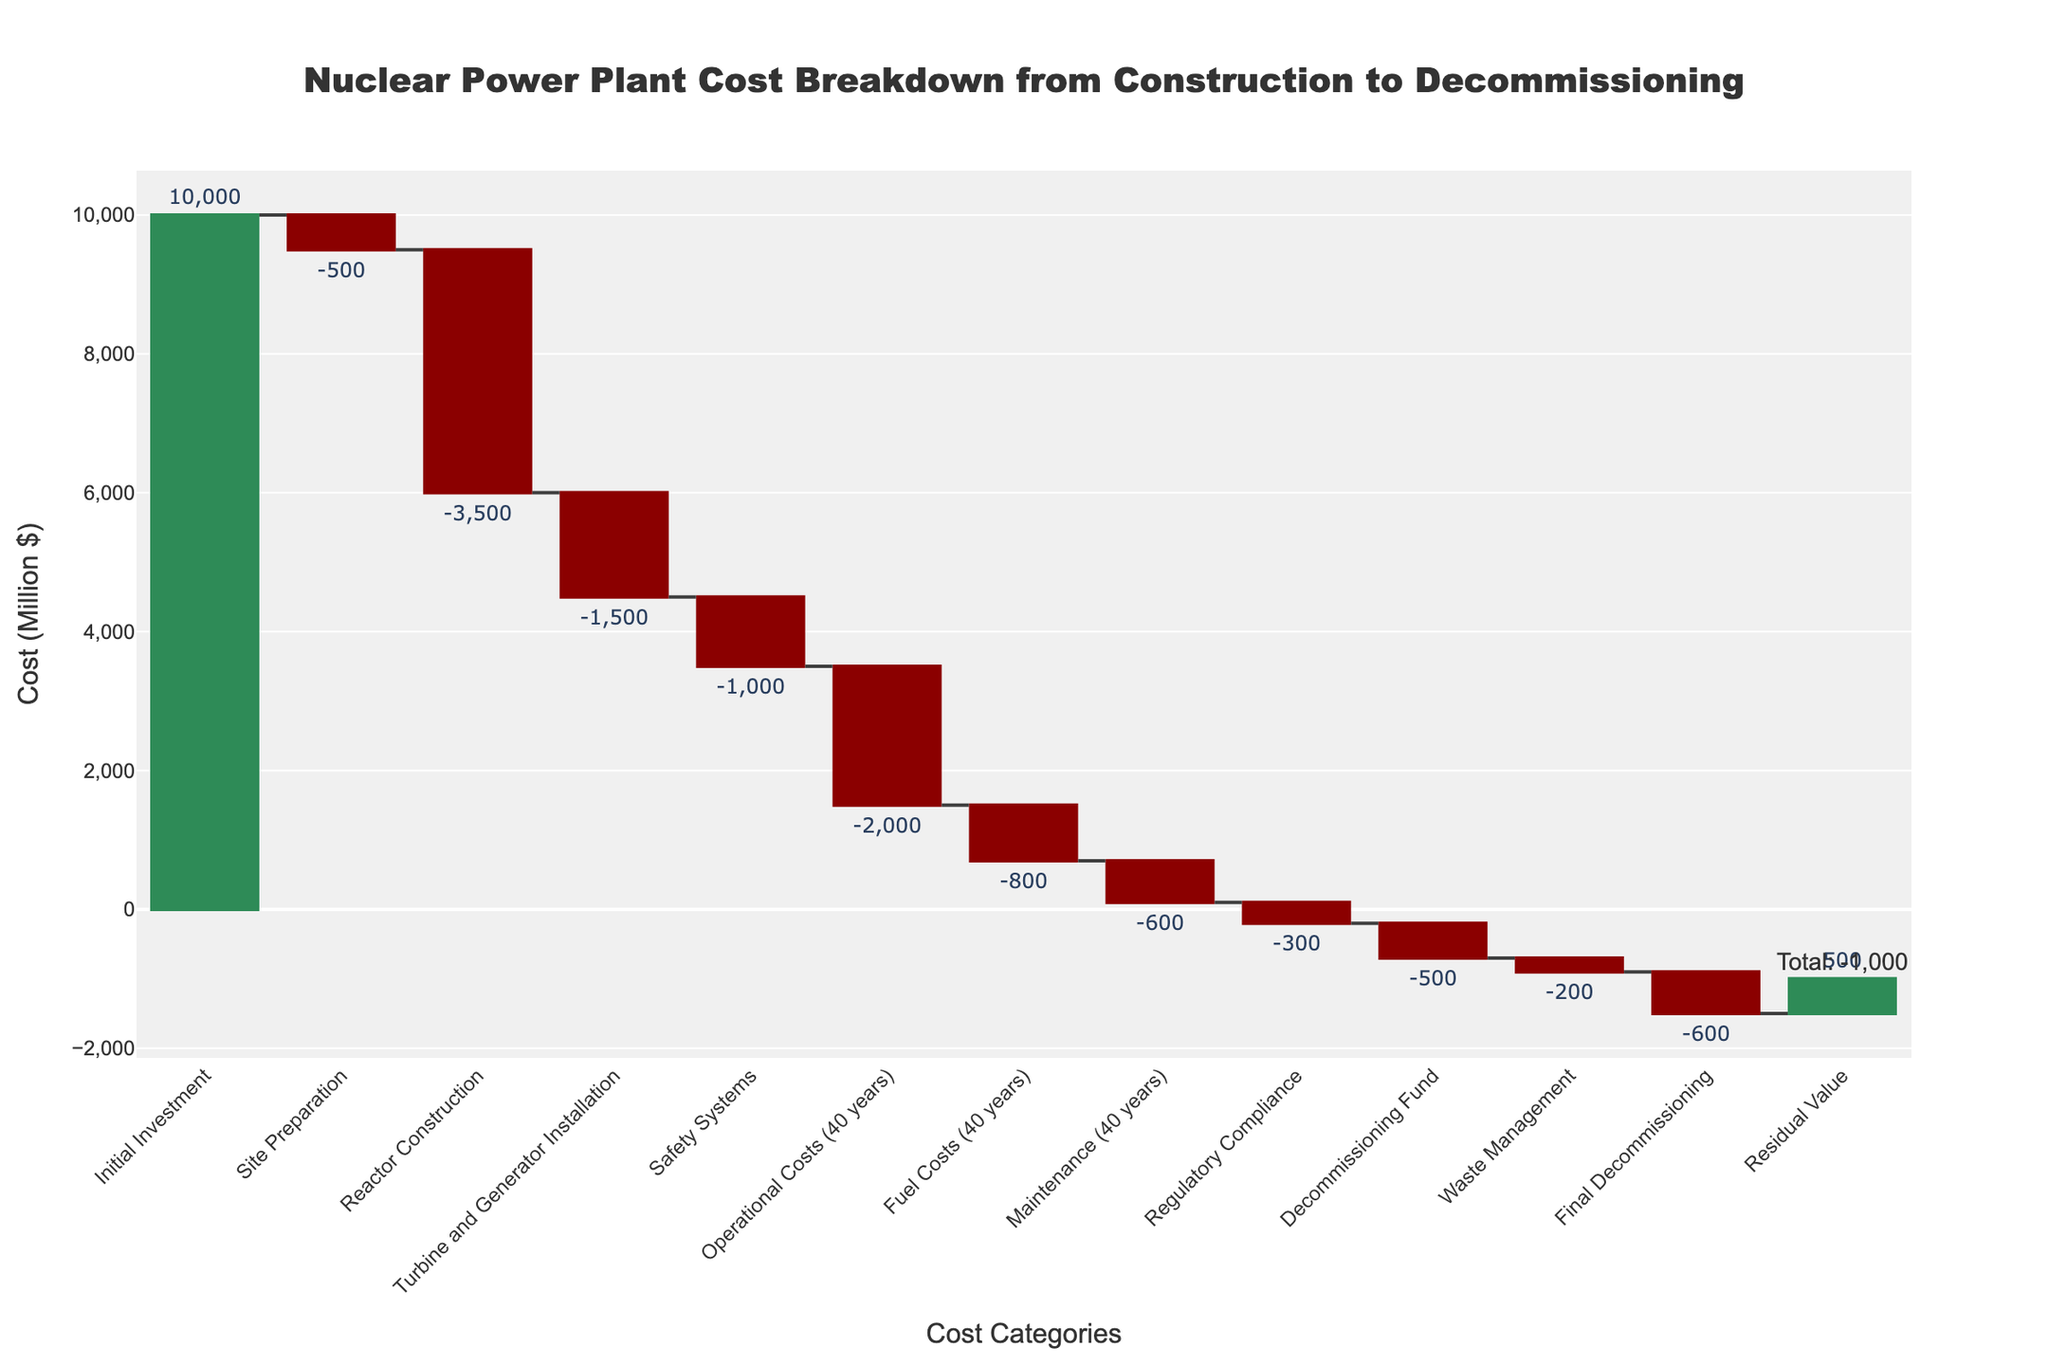What's the total decommissioning cost? To find the total decommissioning cost, we need to sum the values related to decommissioning: "Decommissioning Fund" (-500) and "Final Decommissioning" (-600). Adding these together gives -500 + -600 = -1100.
Answer: -1100 Which cost component has the highest negative value? By examining the chart, we identify the cost components and their values. The component with the largest negative value is "Reactor Construction" which has a value of -3500.
Answer: Reactor Construction What is the total value including the residual value? To find the total value including the residual value, we identify the final value shown. The residual value is added to the cumulative total. According to the chart, the final cumulative value appears to be 0. Subtracting the total negative costs from the initial investment (before adding the residual value) equals -500 + -3500 + -1500 + -1000 + -2000 + -800 + -600 + -300 + -500 + -200 + -600 = -10500. Adding back the residual value (500) gives a final total of 0.
Answer: 0 What is the difference between initial investment and the final decommissioning cost? To determine the difference, subtract the final decommissioning cost (-600) from the initial investment (10000). This results in 10000 - 600 = 9400.
Answer: 9400 Which category contributes positively to the total value? The only category contributing positively to the total value is "Residual Value" with a value of 500.
Answer: Residual Value What is the total operational cost for 40 years? The total operational cost for 40 years is listed directly in the chart. It is shown as -2000.
Answer: -2000 How much higher are the turbine and generator installation costs compared to maintenance costs for 40 years? To determine the difference between the turbine and generator installation costs (-1500) and maintenance costs for 40 years (-600), subtract the latter from the former: -1500 - (-600) = -1500 + 600 = -900.
Answer: -900 Which is costlier, fuel costs for 40 years or safety systems? The fuel costs for 40 years are listed as -800 and the safety systems as -1000. Since -1000 is less than -800, the safety systems are costlier.
Answer: Safety Systems How does the cost of regulatory compliance compare to waste management? To compare, we subtract the cost of waste management (-200) from the cost of regulatory compliance (-300): -300 - (-200) = -300 + 200 = -100. Hence, the cost of regulatory compliance is higher by 100.
Answer: 100 What proportion of the initial investment is spent on reactor construction? The initial investment is 10000, and the reactor construction cost is -3500. The proportion spent on reactor construction is calculated as -3500 / 10000 = -0.35, or 35%.
Answer: 35% 